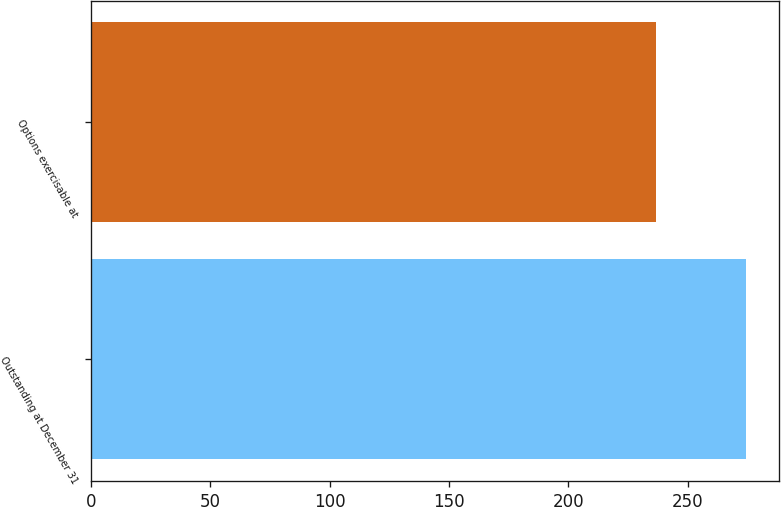Convert chart to OTSL. <chart><loc_0><loc_0><loc_500><loc_500><bar_chart><fcel>Outstanding at December 31<fcel>Options exercisable at<nl><fcel>274.6<fcel>236.5<nl></chart> 